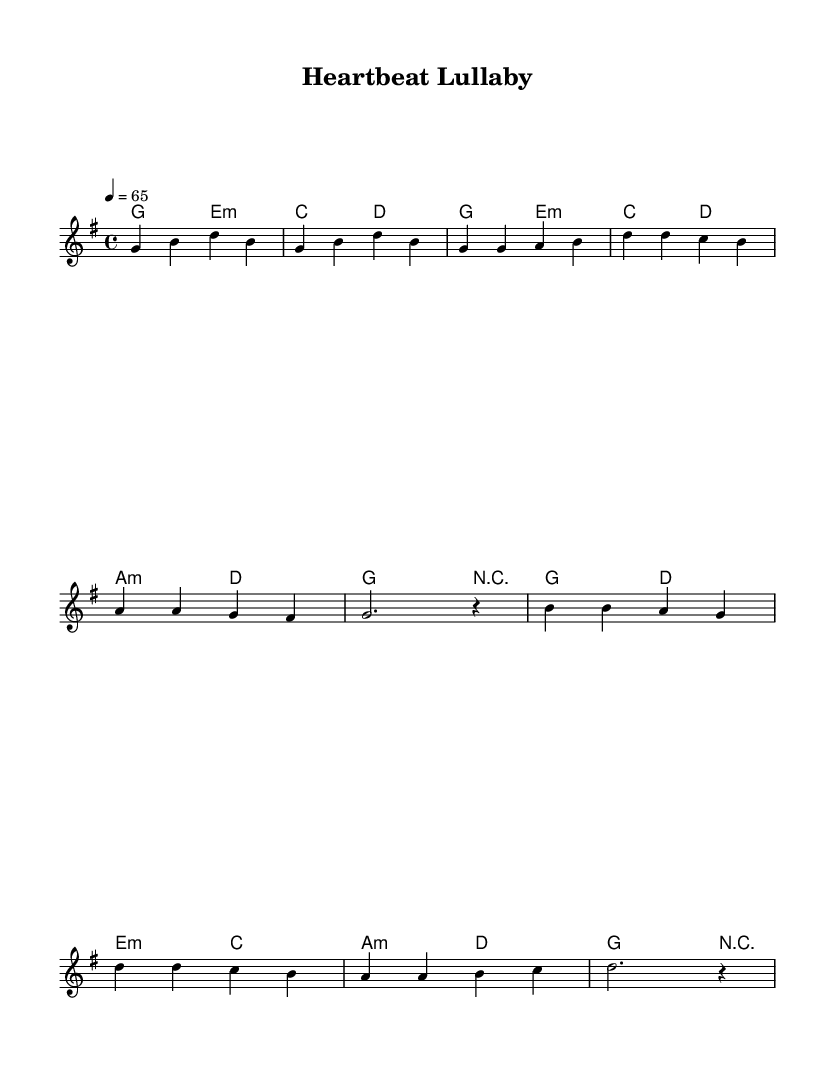What is the key signature of this music? The key signature indicates the key of the piece. The presence of one sharp in the key signature indicates the piece is in G major, which contains the notes G, A, B, C, D, E, and F#.
Answer: G major What is the time signature of this music? The time signature is indicated at the beginning of the score and is expressed as a fraction. In this case, it is 4 over 4, meaning there are four beats in a measure and the quarter note gets one beat.
Answer: 4/4 What is the tempo marking for this piece? The tempo marking is provided with a number at the beginning of the score. It indicates the speed of the music, expressed in beats per minute (BPM). Here, it is marked as 4 equals 65, meaning there are 65 quarter note beats per minute.
Answer: 65 How many measures are in the chorus section? To find the number of measures in the chorus, we count the bars in the written melody section identified as the chorus. The melody has four bars in the chorus part.
Answer: 4 What is the last chord in the score? The final chord can be identified at the end of the harmonies section of the score. The last chord listed is G major.
Answer: G What is the first note of the melody? The first note of the melody is found as the first note in the melody staff. The note is G.
Answer: G What style of music does this sheet represent? This piece falls under the category of soothing pop ballads, which is typically characterized by its calming melodies and emotional lyrics, making it suitable for stress relief and unwinding.
Answer: Pop 